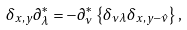<formula> <loc_0><loc_0><loc_500><loc_500>\delta _ { x , y } \partial _ { \lambda } ^ { \ast } = - \partial _ { \nu } ^ { \ast } \left \{ \delta _ { \nu \lambda } \delta _ { x , y - \hat { \nu } } \right \} ,</formula> 